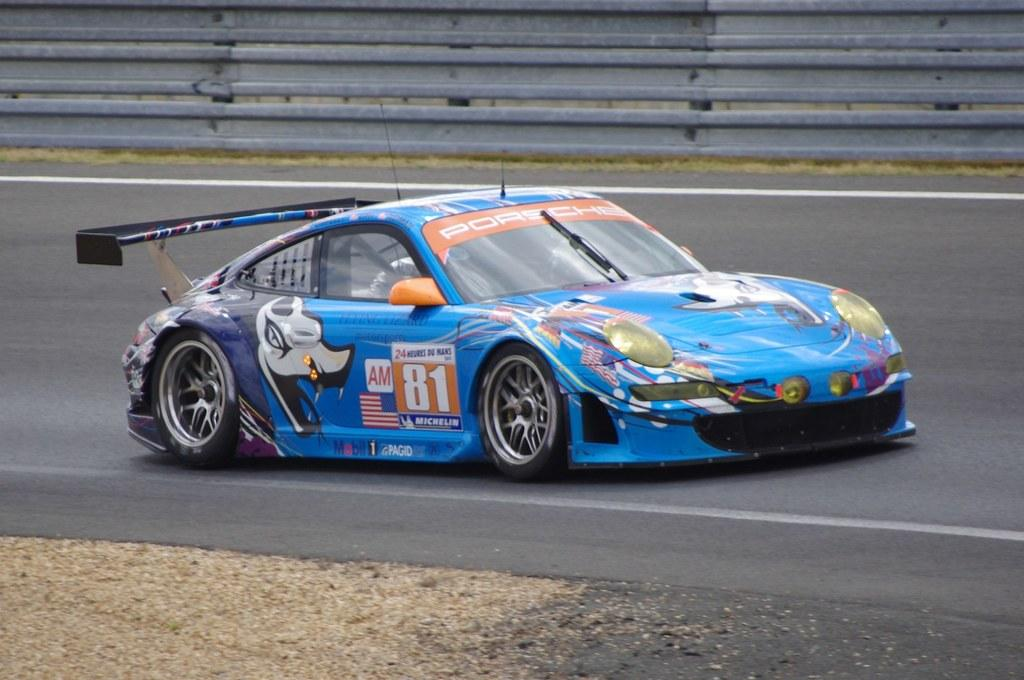What color is the car in the image? The car in the image is blue. Where is the car located in the image? The car is on the road. What is present behind the car in the image? There is a railing behind the car. How many crates are stacked on top of the car in the image? There are no crates present on top of the car in the image. 